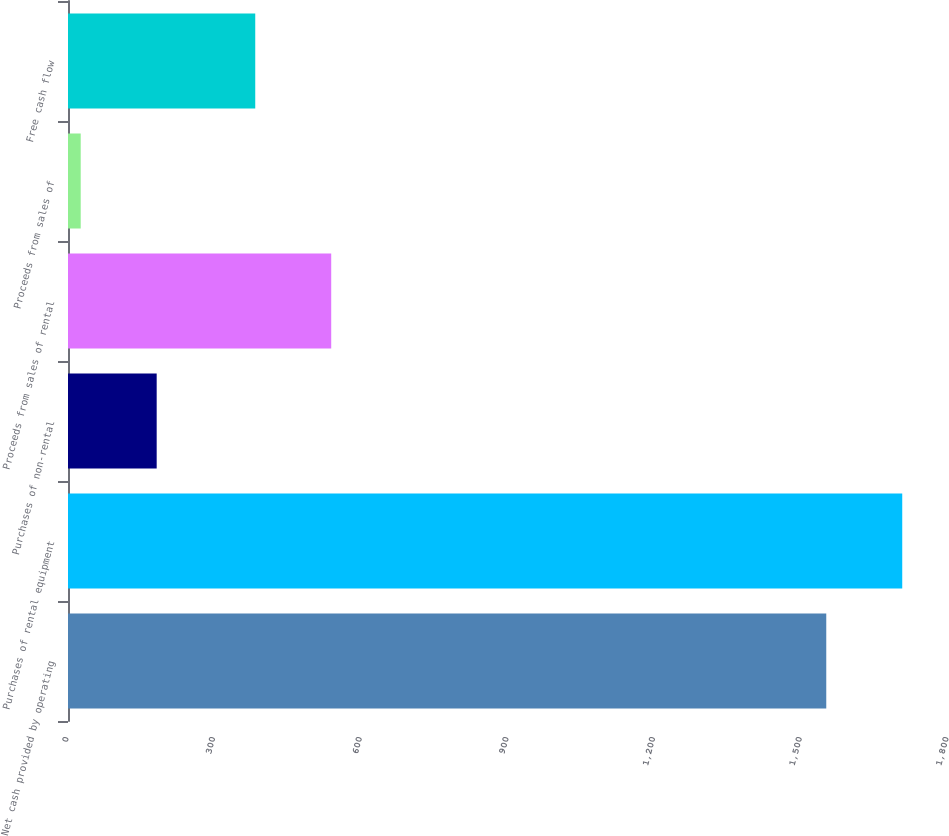Convert chart to OTSL. <chart><loc_0><loc_0><loc_500><loc_500><bar_chart><fcel>Net cash provided by operating<fcel>Purchases of rental equipment<fcel>Purchases of non-rental<fcel>Proceeds from sales of rental<fcel>Proceeds from sales of<fcel>Free cash flow<nl><fcel>1551<fcel>1706.4<fcel>181.4<fcel>538.4<fcel>26<fcel>383<nl></chart> 